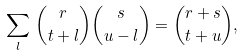Convert formula to latex. <formula><loc_0><loc_0><loc_500><loc_500>\sum _ { l } \, \binom { r } { t + l } \binom { s } { u - l } = \binom { r + s } { t + u } ,</formula> 